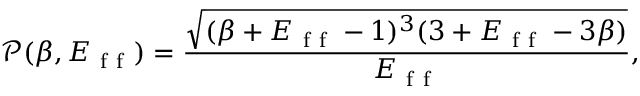Convert formula to latex. <formula><loc_0><loc_0><loc_500><loc_500>\ m a t h s c r { P } ( \beta , E _ { f f } ) = \frac { \sqrt { ( \beta + E _ { f f } - 1 ) ^ { 3 } ( 3 + E _ { f f } - 3 \beta ) } } { E _ { f f } } ,</formula> 